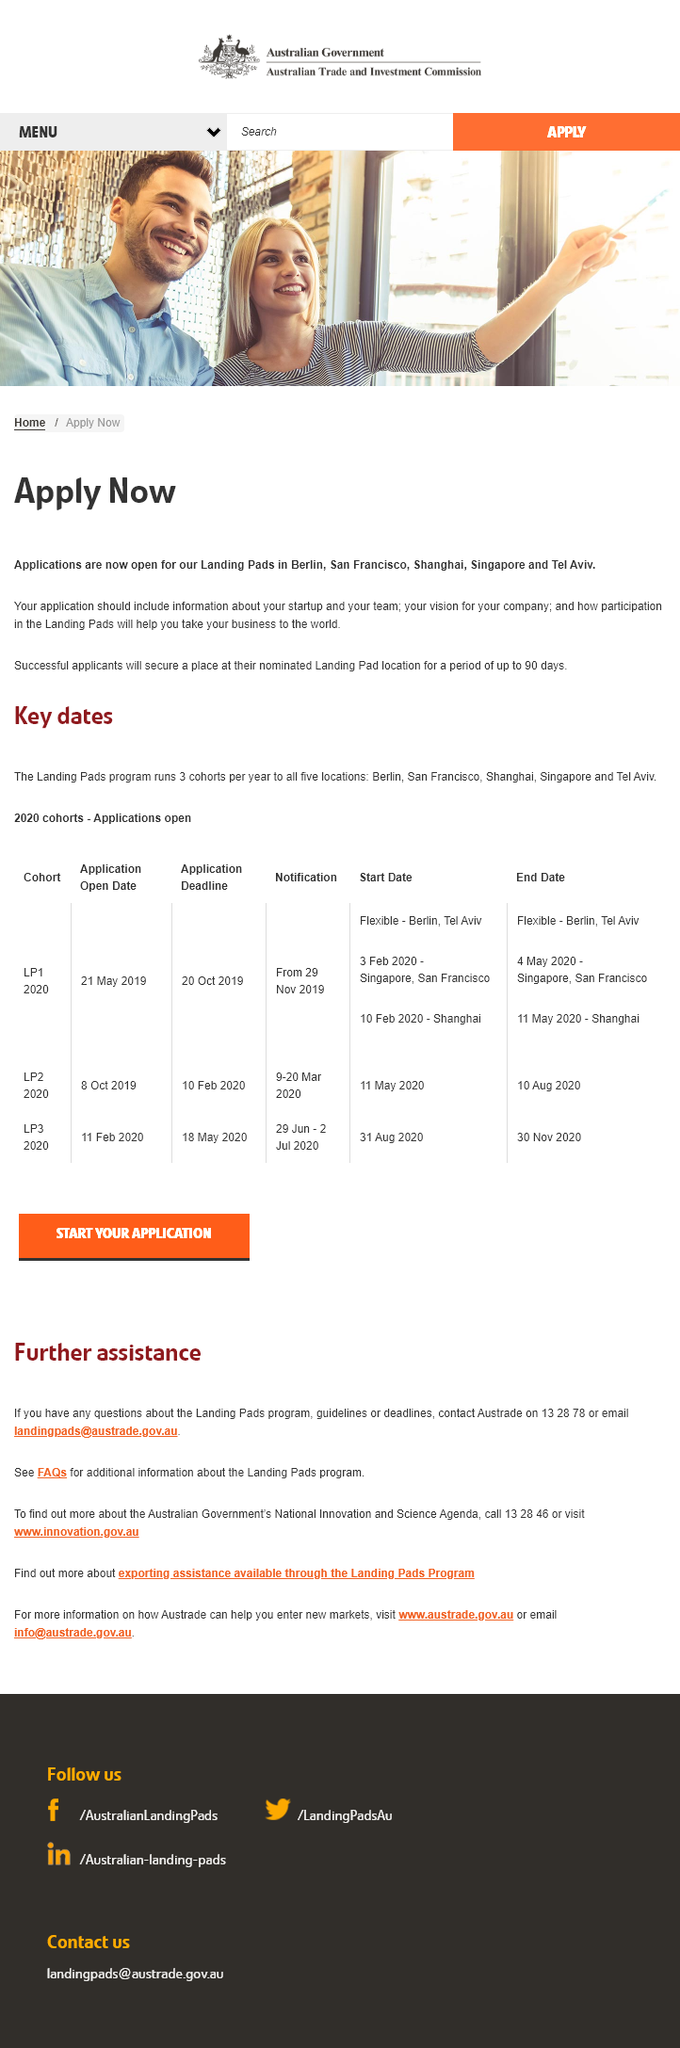Identify some key points in this picture. Successful applicants to the Landing Pads program will secure a place at their nominated Landing Pad location for up to 90 days, where they will receive support and resources to help them establish and grow their business in the UK. Landing Pads are located in Berlin, San Francisco, Shanghai, Singapore, and Tel Aviv. The Landing Pads program runs three cohorts per year, with each cohort consisting of how many students? 